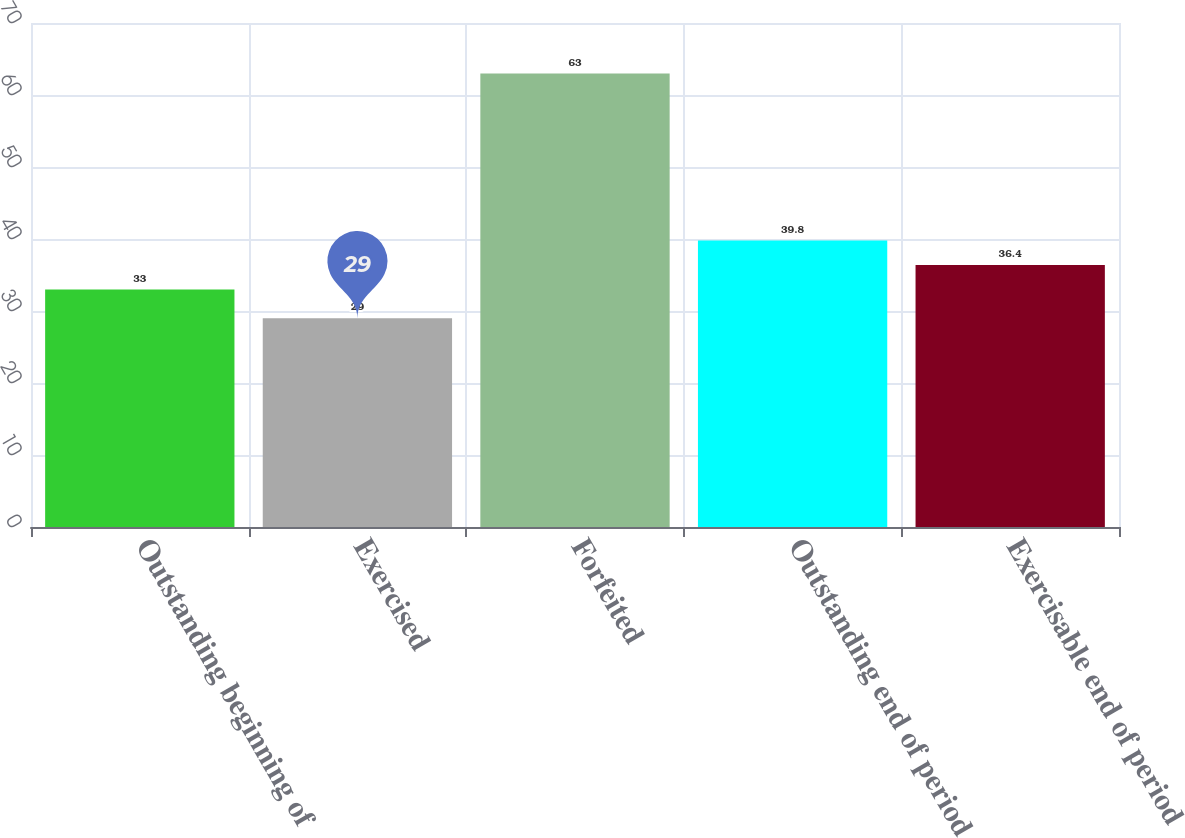Convert chart to OTSL. <chart><loc_0><loc_0><loc_500><loc_500><bar_chart><fcel>Outstanding beginning of<fcel>Exercised<fcel>Forfeited<fcel>Outstanding end of period<fcel>Exercisable end of period<nl><fcel>33<fcel>29<fcel>63<fcel>39.8<fcel>36.4<nl></chart> 